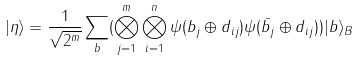Convert formula to latex. <formula><loc_0><loc_0><loc_500><loc_500>| \eta \rangle = \frac { 1 } { \sqrt { 2 ^ { m } } } \sum _ { b } ( \bigotimes _ { j = 1 } ^ { m } \bigotimes _ { i = 1 } ^ { n } \psi ( b _ { j } \oplus d _ { i j } ) \psi ( \bar { b _ { j } } \oplus d _ { i j } ) ) | b \rangle _ { B }</formula> 